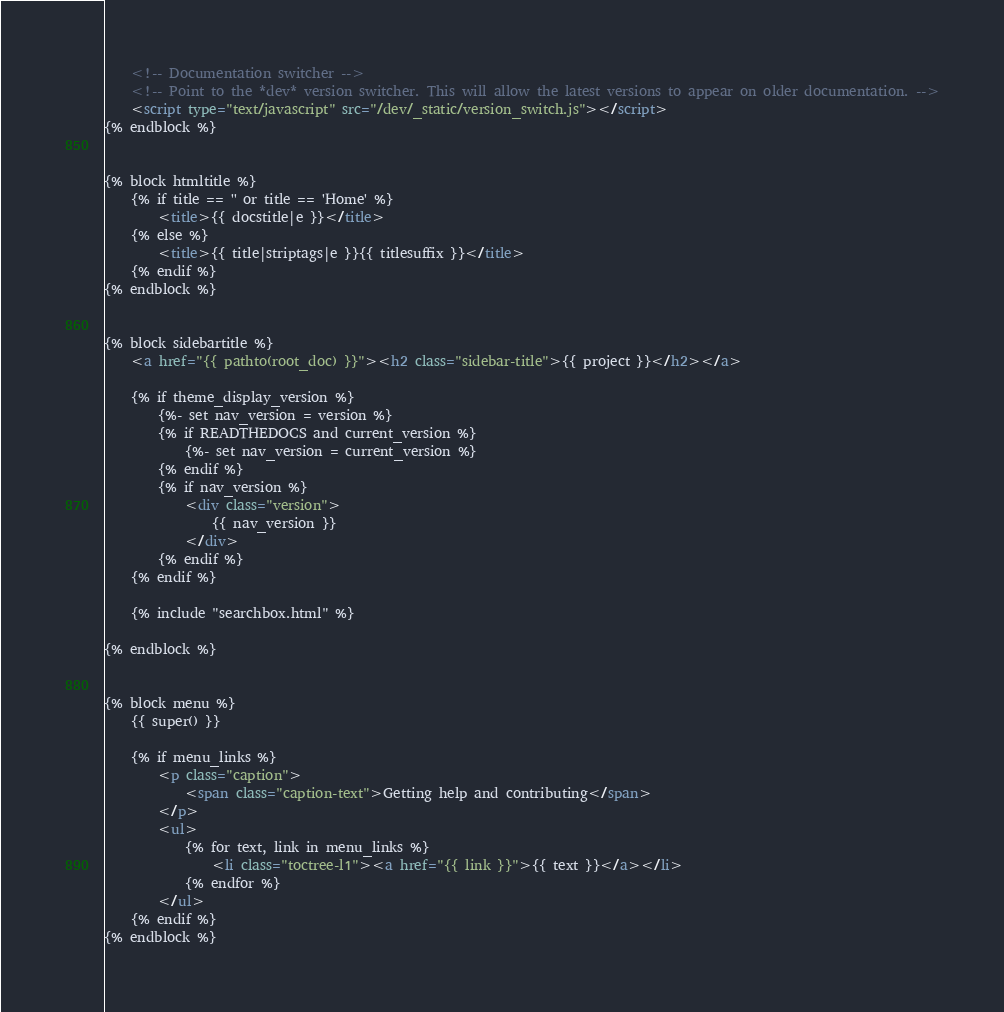<code> <loc_0><loc_0><loc_500><loc_500><_HTML_>
    <!-- Documentation switcher -->
    <!-- Point to the *dev* version switcher. This will allow the latest versions to appear on older documentation. -->
    <script type="text/javascript" src="/dev/_static/version_switch.js"></script>
{% endblock %}


{% block htmltitle %}
    {% if title == '' or title == 'Home' %}
        <title>{{ docstitle|e }}</title>
    {% else %}
        <title>{{ title|striptags|e }}{{ titlesuffix }}</title>
    {% endif %}
{% endblock %}


{% block sidebartitle %}
    <a href="{{ pathto(root_doc) }}"><h2 class="sidebar-title">{{ project }}</h2></a>

    {% if theme_display_version %}
        {%- set nav_version = version %}
        {% if READTHEDOCS and current_version %}
            {%- set nav_version = current_version %}
        {% endif %}
        {% if nav_version %}
            <div class="version">
                {{ nav_version }}
            </div>
        {% endif %}
    {% endif %}

    {% include "searchbox.html" %}

{% endblock %}


{% block menu %}
    {{ super() }}

    {% if menu_links %}
        <p class="caption">
            <span class="caption-text">Getting help and contributing</span>
        </p>
        <ul>
            {% for text, link in menu_links %}
                <li class="toctree-l1"><a href="{{ link }}">{{ text }}</a></li>
            {% endfor %}
        </ul>
    {% endif %}
{% endblock %}
</code> 